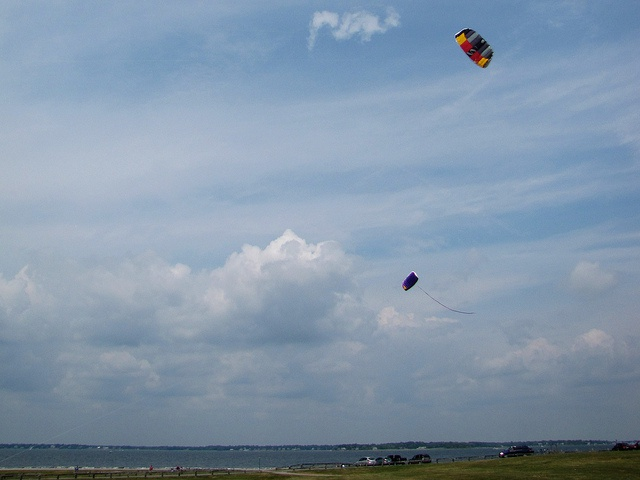Describe the objects in this image and their specific colors. I can see kite in darkgray, black, gray, maroon, and brown tones, car in darkgray, black, navy, and purple tones, kite in darkgray, navy, black, and purple tones, car in darkgray, black, purple, navy, and gray tones, and car in darkgray, black, and gray tones in this image. 